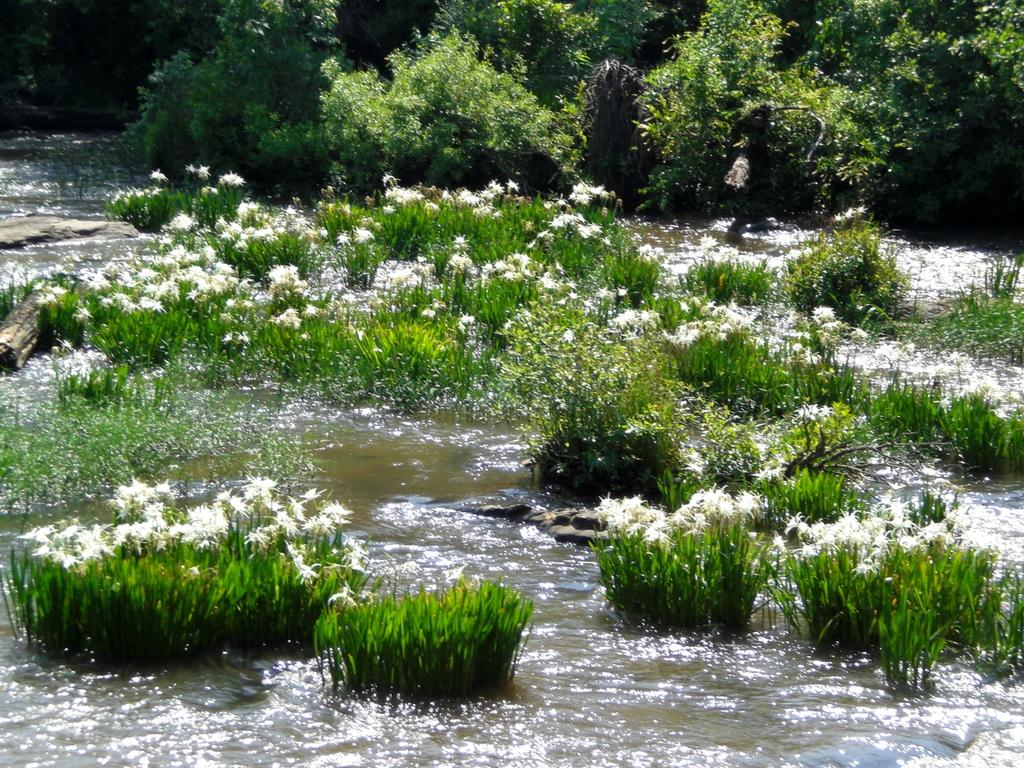What is the primary element visible in the image? There is water in the image. What type of vegetation can be seen in the image? There are flowers, grass, plants, and trees in the image. Can you describe the background of the image? There are trees in the background of the image. What type of sink is visible in the image? There is no sink present in the image. Can you tell me what the father is doing in the image? There is no father or any person present in the image. 